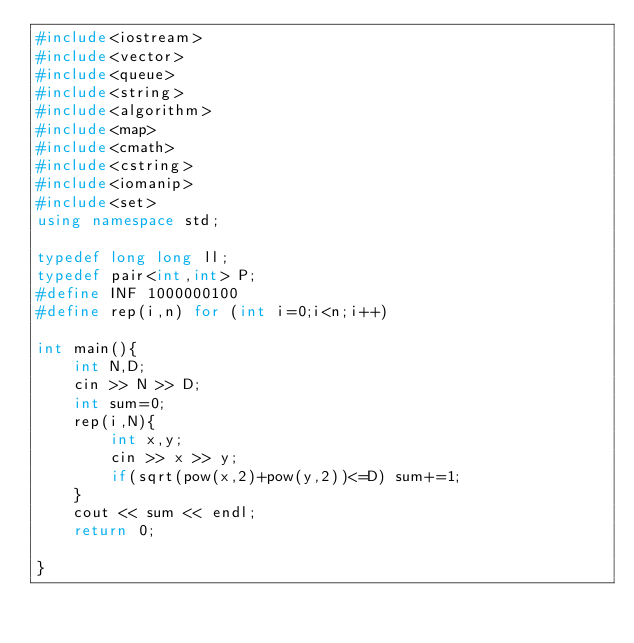<code> <loc_0><loc_0><loc_500><loc_500><_C++_>#include<iostream>
#include<vector>
#include<queue>
#include<string>
#include<algorithm>
#include<map>
#include<cmath>
#include<cstring>
#include<iomanip>
#include<set>
using namespace std;

typedef long long ll;
typedef pair<int,int> P;
#define INF 1000000100
#define rep(i,n) for (int i=0;i<n;i++)

int main(){
    int N,D;
    cin >> N >> D;
    int sum=0;
    rep(i,N){
        int x,y;
        cin >> x >> y;
        if(sqrt(pow(x,2)+pow(y,2))<=D) sum+=1;
    }
    cout << sum << endl;
    return 0;

}</code> 